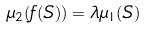<formula> <loc_0><loc_0><loc_500><loc_500>\mu _ { 2 } ( f ( S ) ) = \lambda \mu _ { 1 } ( S )</formula> 